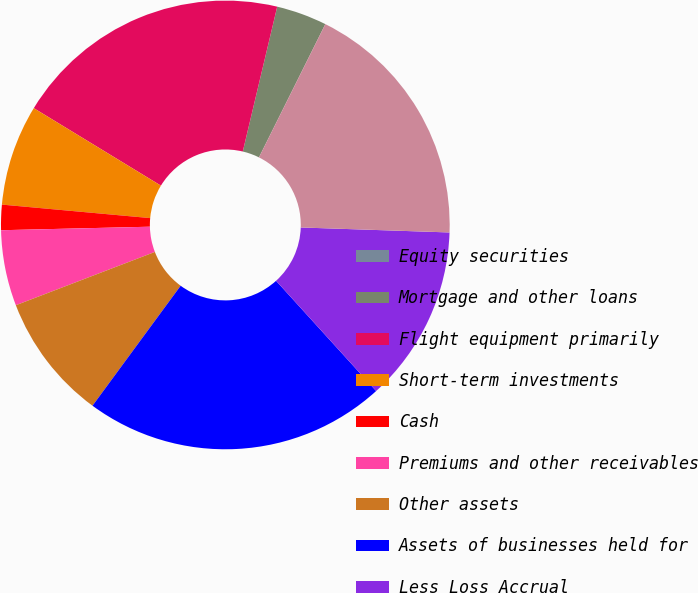Convert chart. <chart><loc_0><loc_0><loc_500><loc_500><pie_chart><fcel>Equity securities<fcel>Mortgage and other loans<fcel>Flight equipment primarily<fcel>Short-term investments<fcel>Cash<fcel>Premiums and other receivables<fcel>Other assets<fcel>Assets of businesses held for<fcel>Less Loss Accrual<fcel>Total assets held for sale<nl><fcel>0.0%<fcel>3.64%<fcel>20.0%<fcel>7.27%<fcel>1.82%<fcel>5.45%<fcel>9.09%<fcel>21.82%<fcel>12.73%<fcel>18.18%<nl></chart> 